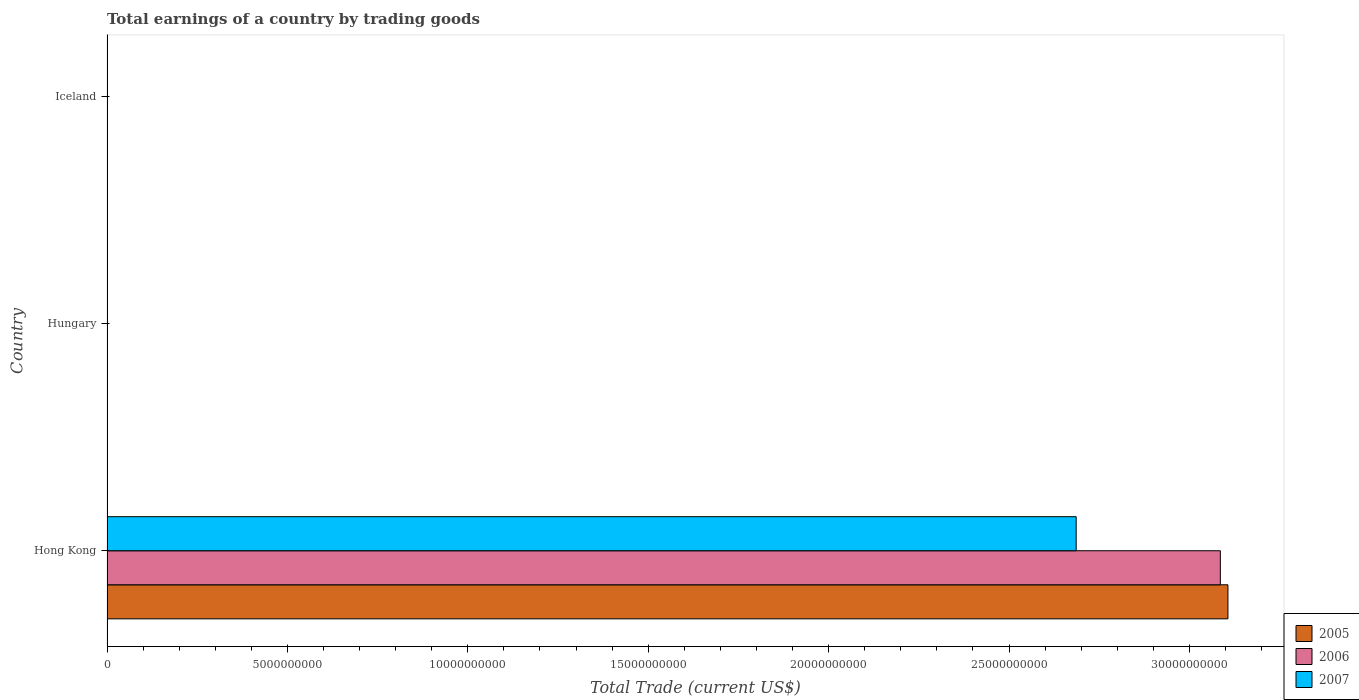How many bars are there on the 2nd tick from the top?
Make the answer very short. 0. What is the label of the 3rd group of bars from the top?
Ensure brevity in your answer.  Hong Kong. In how many cases, is the number of bars for a given country not equal to the number of legend labels?
Your answer should be compact. 2. What is the total earnings in 2007 in Hong Kong?
Provide a short and direct response. 2.69e+1. Across all countries, what is the maximum total earnings in 2006?
Give a very brief answer. 3.09e+1. Across all countries, what is the minimum total earnings in 2006?
Ensure brevity in your answer.  0. In which country was the total earnings in 2007 maximum?
Ensure brevity in your answer.  Hong Kong. What is the total total earnings in 2007 in the graph?
Your answer should be compact. 2.69e+1. What is the difference between the total earnings in 2005 in Hong Kong and the total earnings in 2007 in Hungary?
Offer a terse response. 3.11e+1. What is the average total earnings in 2005 per country?
Provide a succinct answer. 1.04e+1. What is the difference between the total earnings in 2005 and total earnings in 2007 in Hong Kong?
Your response must be concise. 4.21e+09. What is the difference between the highest and the lowest total earnings in 2005?
Your answer should be very brief. 3.11e+1. Is it the case that in every country, the sum of the total earnings in 2005 and total earnings in 2007 is greater than the total earnings in 2006?
Give a very brief answer. No. How many bars are there?
Your answer should be compact. 3. How many countries are there in the graph?
Make the answer very short. 3. What is the difference between two consecutive major ticks on the X-axis?
Your answer should be very brief. 5.00e+09. Does the graph contain any zero values?
Your answer should be compact. Yes. Does the graph contain grids?
Offer a very short reply. No. Where does the legend appear in the graph?
Make the answer very short. Bottom right. How many legend labels are there?
Keep it short and to the point. 3. How are the legend labels stacked?
Your response must be concise. Vertical. What is the title of the graph?
Provide a short and direct response. Total earnings of a country by trading goods. Does "1960" appear as one of the legend labels in the graph?
Give a very brief answer. No. What is the label or title of the X-axis?
Provide a short and direct response. Total Trade (current US$). What is the Total Trade (current US$) in 2005 in Hong Kong?
Make the answer very short. 3.11e+1. What is the Total Trade (current US$) of 2006 in Hong Kong?
Your response must be concise. 3.09e+1. What is the Total Trade (current US$) of 2007 in Hong Kong?
Ensure brevity in your answer.  2.69e+1. What is the Total Trade (current US$) of 2005 in Hungary?
Provide a short and direct response. 0. What is the Total Trade (current US$) in 2005 in Iceland?
Offer a very short reply. 0. What is the Total Trade (current US$) of 2007 in Iceland?
Your answer should be very brief. 0. Across all countries, what is the maximum Total Trade (current US$) in 2005?
Your response must be concise. 3.11e+1. Across all countries, what is the maximum Total Trade (current US$) in 2006?
Your answer should be very brief. 3.09e+1. Across all countries, what is the maximum Total Trade (current US$) in 2007?
Offer a very short reply. 2.69e+1. Across all countries, what is the minimum Total Trade (current US$) in 2005?
Provide a short and direct response. 0. Across all countries, what is the minimum Total Trade (current US$) in 2006?
Give a very brief answer. 0. Across all countries, what is the minimum Total Trade (current US$) of 2007?
Ensure brevity in your answer.  0. What is the total Total Trade (current US$) of 2005 in the graph?
Your answer should be compact. 3.11e+1. What is the total Total Trade (current US$) of 2006 in the graph?
Your response must be concise. 3.09e+1. What is the total Total Trade (current US$) of 2007 in the graph?
Your response must be concise. 2.69e+1. What is the average Total Trade (current US$) in 2005 per country?
Make the answer very short. 1.04e+1. What is the average Total Trade (current US$) in 2006 per country?
Keep it short and to the point. 1.03e+1. What is the average Total Trade (current US$) of 2007 per country?
Provide a short and direct response. 8.95e+09. What is the difference between the Total Trade (current US$) in 2005 and Total Trade (current US$) in 2006 in Hong Kong?
Your answer should be compact. 2.11e+08. What is the difference between the Total Trade (current US$) of 2005 and Total Trade (current US$) of 2007 in Hong Kong?
Your answer should be very brief. 4.21e+09. What is the difference between the Total Trade (current US$) of 2006 and Total Trade (current US$) of 2007 in Hong Kong?
Offer a very short reply. 4.00e+09. What is the difference between the highest and the lowest Total Trade (current US$) of 2005?
Offer a terse response. 3.11e+1. What is the difference between the highest and the lowest Total Trade (current US$) in 2006?
Your answer should be compact. 3.09e+1. What is the difference between the highest and the lowest Total Trade (current US$) in 2007?
Keep it short and to the point. 2.69e+1. 